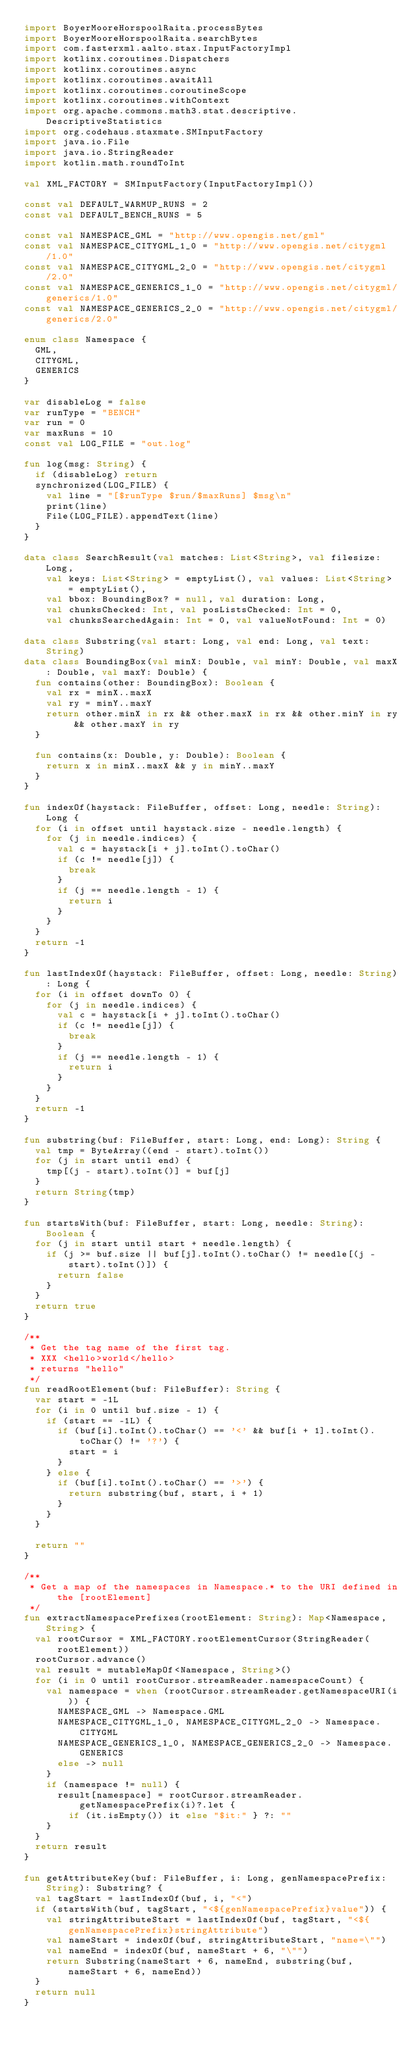Convert code to text. <code><loc_0><loc_0><loc_500><loc_500><_Kotlin_>import BoyerMooreHorspoolRaita.processBytes
import BoyerMooreHorspoolRaita.searchBytes
import com.fasterxml.aalto.stax.InputFactoryImpl
import kotlinx.coroutines.Dispatchers
import kotlinx.coroutines.async
import kotlinx.coroutines.awaitAll
import kotlinx.coroutines.coroutineScope
import kotlinx.coroutines.withContext
import org.apache.commons.math3.stat.descriptive.DescriptiveStatistics
import org.codehaus.staxmate.SMInputFactory
import java.io.File
import java.io.StringReader
import kotlin.math.roundToInt

val XML_FACTORY = SMInputFactory(InputFactoryImpl())

const val DEFAULT_WARMUP_RUNS = 2
const val DEFAULT_BENCH_RUNS = 5

const val NAMESPACE_GML = "http://www.opengis.net/gml"
const val NAMESPACE_CITYGML_1_0 = "http://www.opengis.net/citygml/1.0"
const val NAMESPACE_CITYGML_2_0 = "http://www.opengis.net/citygml/2.0"
const val NAMESPACE_GENERICS_1_0 = "http://www.opengis.net/citygml/generics/1.0"
const val NAMESPACE_GENERICS_2_0 = "http://www.opengis.net/citygml/generics/2.0"

enum class Namespace {
  GML,
  CITYGML,
  GENERICS
}

var disableLog = false
var runType = "BENCH"
var run = 0
var maxRuns = 10
const val LOG_FILE = "out.log"

fun log(msg: String) {
  if (disableLog) return
  synchronized(LOG_FILE) {
    val line = "[$runType $run/$maxRuns] $msg\n"
    print(line)
    File(LOG_FILE).appendText(line)
  }
}

data class SearchResult(val matches: List<String>, val filesize: Long,
    val keys: List<String> = emptyList(), val values: List<String> = emptyList(),
    val bbox: BoundingBox? = null, val duration: Long,
    val chunksChecked: Int, val posListsChecked: Int = 0,
    val chunksSearchedAgain: Int = 0, val valueNotFound: Int = 0)

data class Substring(val start: Long, val end: Long, val text: String)
data class BoundingBox(val minX: Double, val minY: Double, val maxX: Double, val maxY: Double) {
  fun contains(other: BoundingBox): Boolean {
    val rx = minX..maxX
    val ry = minY..maxY
    return other.minX in rx && other.maxX in rx && other.minY in ry && other.maxY in ry
  }

  fun contains(x: Double, y: Double): Boolean {
    return x in minX..maxX && y in minY..maxY
  }
}

fun indexOf(haystack: FileBuffer, offset: Long, needle: String): Long {
  for (i in offset until haystack.size - needle.length) {
    for (j in needle.indices) {
      val c = haystack[i + j].toInt().toChar()
      if (c != needle[j]) {
        break
      }
      if (j == needle.length - 1) {
        return i
      }
    }
  }
  return -1
}

fun lastIndexOf(haystack: FileBuffer, offset: Long, needle: String): Long {
  for (i in offset downTo 0) {
    for (j in needle.indices) {
      val c = haystack[i + j].toInt().toChar()
      if (c != needle[j]) {
        break
      }
      if (j == needle.length - 1) {
        return i
      }
    }
  }
  return -1
}

fun substring(buf: FileBuffer, start: Long, end: Long): String {
  val tmp = ByteArray((end - start).toInt())
  for (j in start until end) {
    tmp[(j - start).toInt()] = buf[j]
  }
  return String(tmp)
}

fun startsWith(buf: FileBuffer, start: Long, needle: String): Boolean {
  for (j in start until start + needle.length) {
    if (j >= buf.size || buf[j].toInt().toChar() != needle[(j - start).toInt()]) {
      return false
    }
  }
  return true
}

/**
 * Get the tag name of the first tag.
 * XXX <hello>world</hello>
 * returns "hello"
 */
fun readRootElement(buf: FileBuffer): String {
  var start = -1L
  for (i in 0 until buf.size - 1) {
    if (start == -1L) {
      if (buf[i].toInt().toChar() == '<' && buf[i + 1].toInt().toChar() != '?') {
        start = i
      }
    } else {
      if (buf[i].toInt().toChar() == '>') {
        return substring(buf, start, i + 1)
      }
    }
  }

  return ""
}

/**
 * Get a map of the namespaces in Namespace.* to the URI defined in the [rootElement]
 */
fun extractNamespacePrefixes(rootElement: String): Map<Namespace, String> {
  val rootCursor = XML_FACTORY.rootElementCursor(StringReader(rootElement))
  rootCursor.advance()
  val result = mutableMapOf<Namespace, String>()
  for (i in 0 until rootCursor.streamReader.namespaceCount) {
    val namespace = when (rootCursor.streamReader.getNamespaceURI(i)) {
      NAMESPACE_GML -> Namespace.GML
      NAMESPACE_CITYGML_1_0, NAMESPACE_CITYGML_2_0 -> Namespace.CITYGML
      NAMESPACE_GENERICS_1_0, NAMESPACE_GENERICS_2_0 -> Namespace.GENERICS
      else -> null
    }
    if (namespace != null) {
      result[namespace] = rootCursor.streamReader.getNamespacePrefix(i)?.let {
        if (it.isEmpty()) it else "$it:" } ?: ""
    }
  }
  return result
}

fun getAttributeKey(buf: FileBuffer, i: Long, genNamespacePrefix: String): Substring? {
  val tagStart = lastIndexOf(buf, i, "<")
  if (startsWith(buf, tagStart, "<${genNamespacePrefix}value")) {
    val stringAttributeStart = lastIndexOf(buf, tagStart, "<${genNamespacePrefix}stringAttribute")
    val nameStart = indexOf(buf, stringAttributeStart, "name=\"")
    val nameEnd = indexOf(buf, nameStart + 6, "\"")
    return Substring(nameStart + 6, nameEnd, substring(buf, nameStart + 6, nameEnd))
  }
  return null
}
</code> 